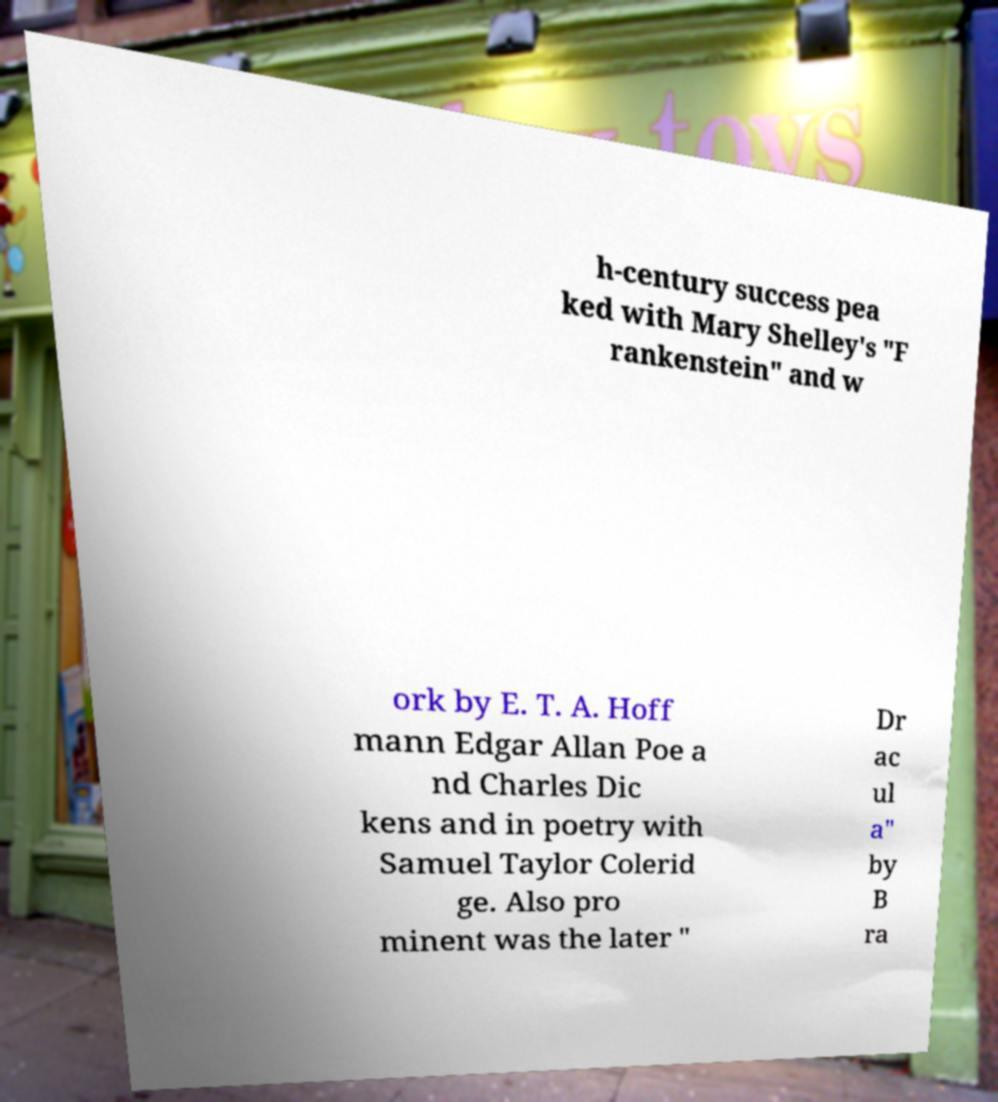I need the written content from this picture converted into text. Can you do that? h-century success pea ked with Mary Shelley's "F rankenstein" and w ork by E. T. A. Hoff mann Edgar Allan Poe a nd Charles Dic kens and in poetry with Samuel Taylor Colerid ge. Also pro minent was the later " Dr ac ul a" by B ra 